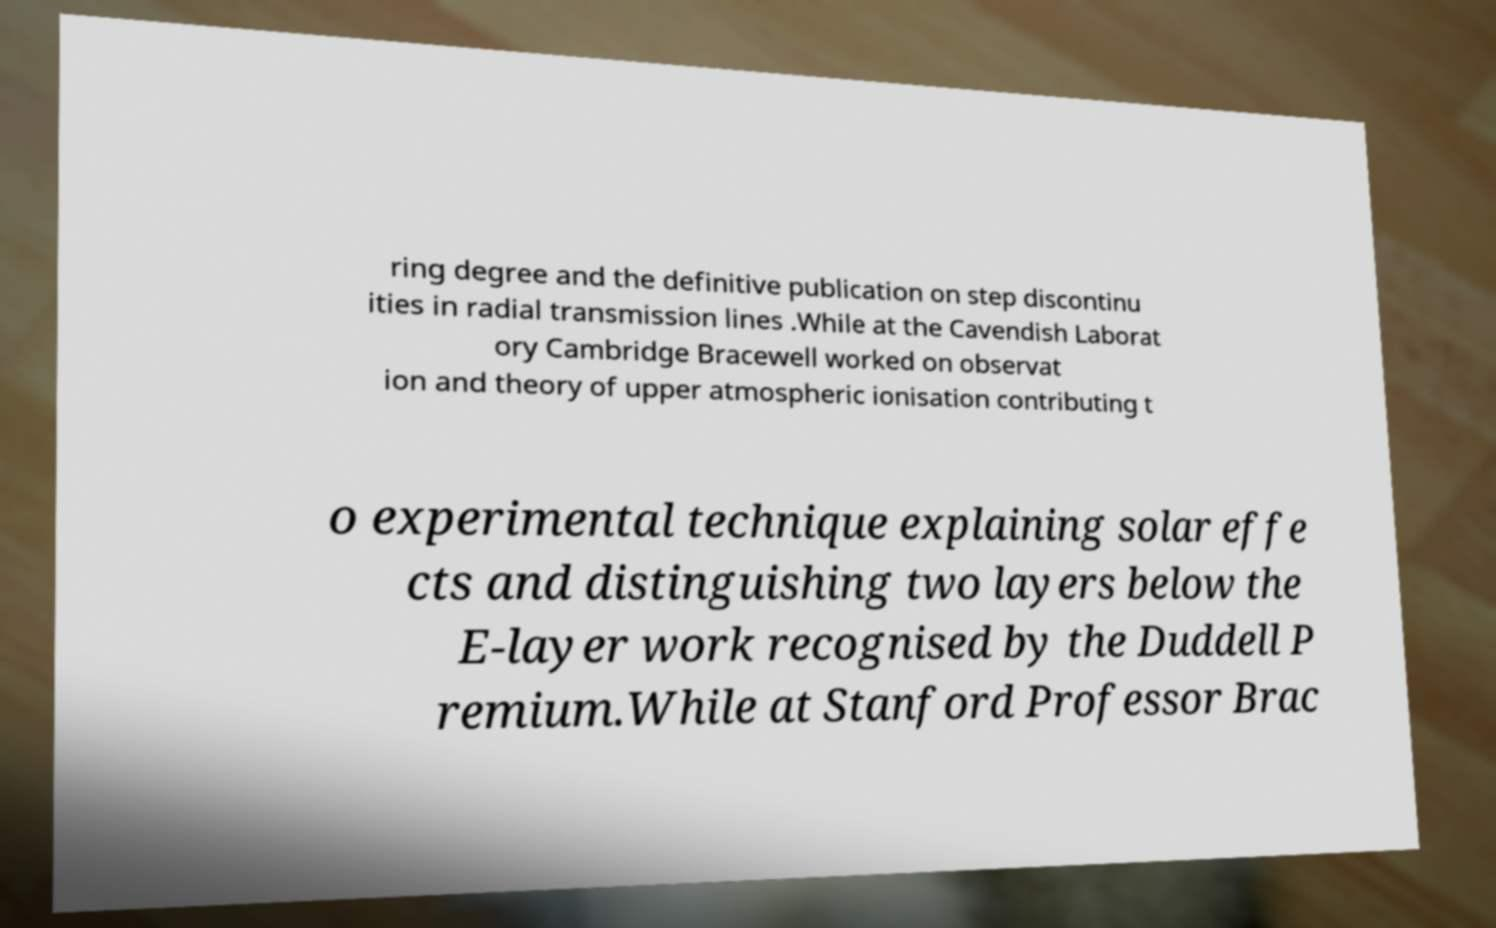Please identify and transcribe the text found in this image. ring degree and the definitive publication on step discontinu ities in radial transmission lines .While at the Cavendish Laborat ory Cambridge Bracewell worked on observat ion and theory of upper atmospheric ionisation contributing t o experimental technique explaining solar effe cts and distinguishing two layers below the E-layer work recognised by the Duddell P remium.While at Stanford Professor Brac 